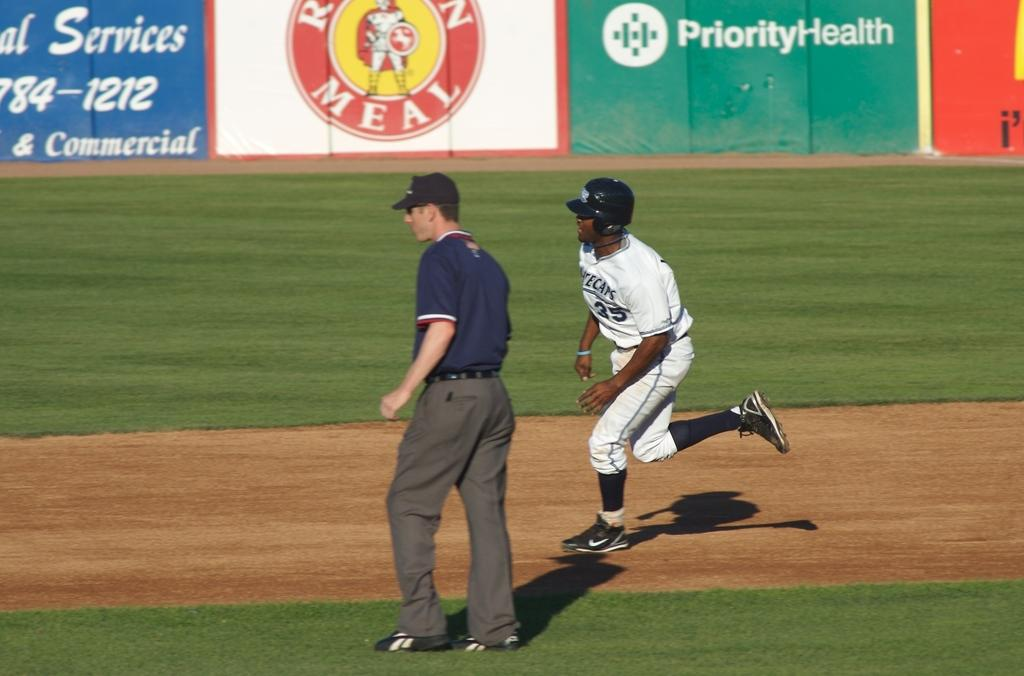<image>
Render a clear and concise summary of the photo. The company Priority Health is a sponsor of a baseball team. 